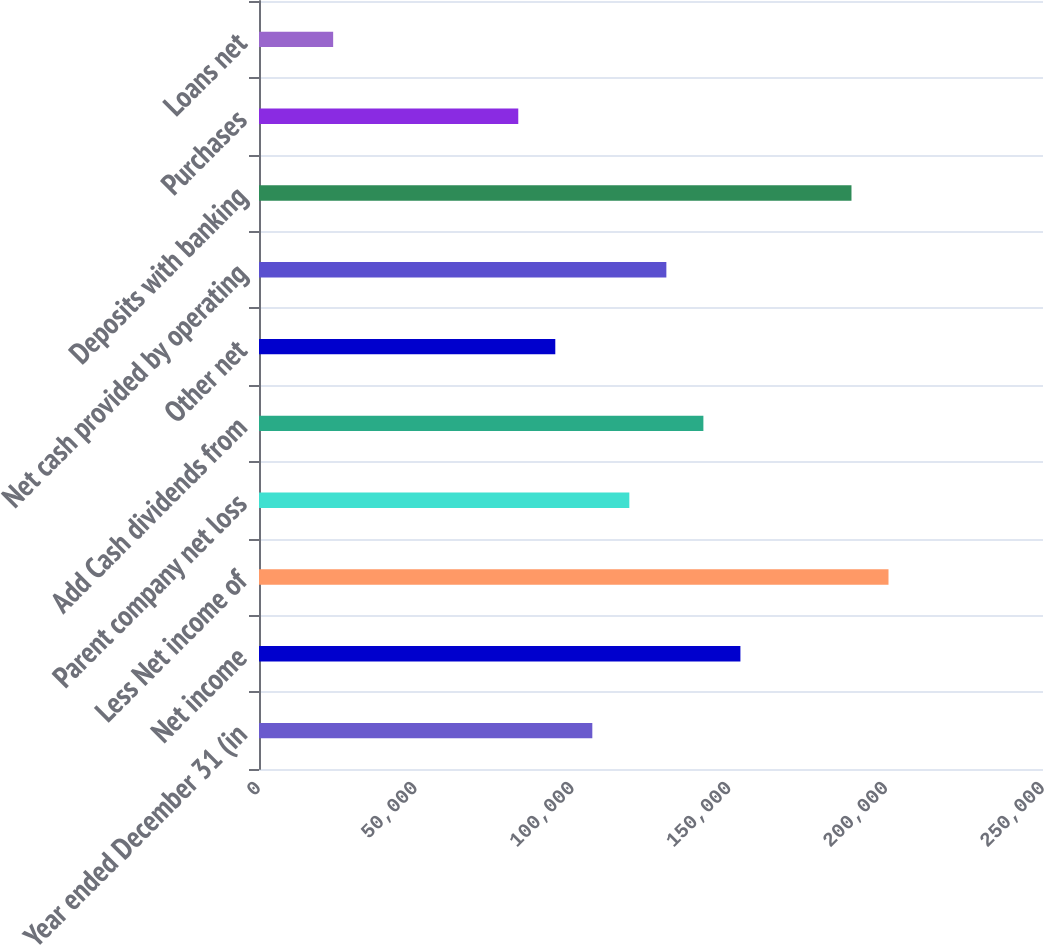Convert chart. <chart><loc_0><loc_0><loc_500><loc_500><bar_chart><fcel>Year ended December 31 (in<fcel>Net income<fcel>Less Net income of<fcel>Parent company net loss<fcel>Add Cash dividends from<fcel>Other net<fcel>Net cash provided by operating<fcel>Deposits with banking<fcel>Purchases<fcel>Loans net<nl><fcel>106287<fcel>153510<fcel>200734<fcel>118093<fcel>141705<fcel>94481.4<fcel>129899<fcel>188928<fcel>82675.6<fcel>23646.6<nl></chart> 